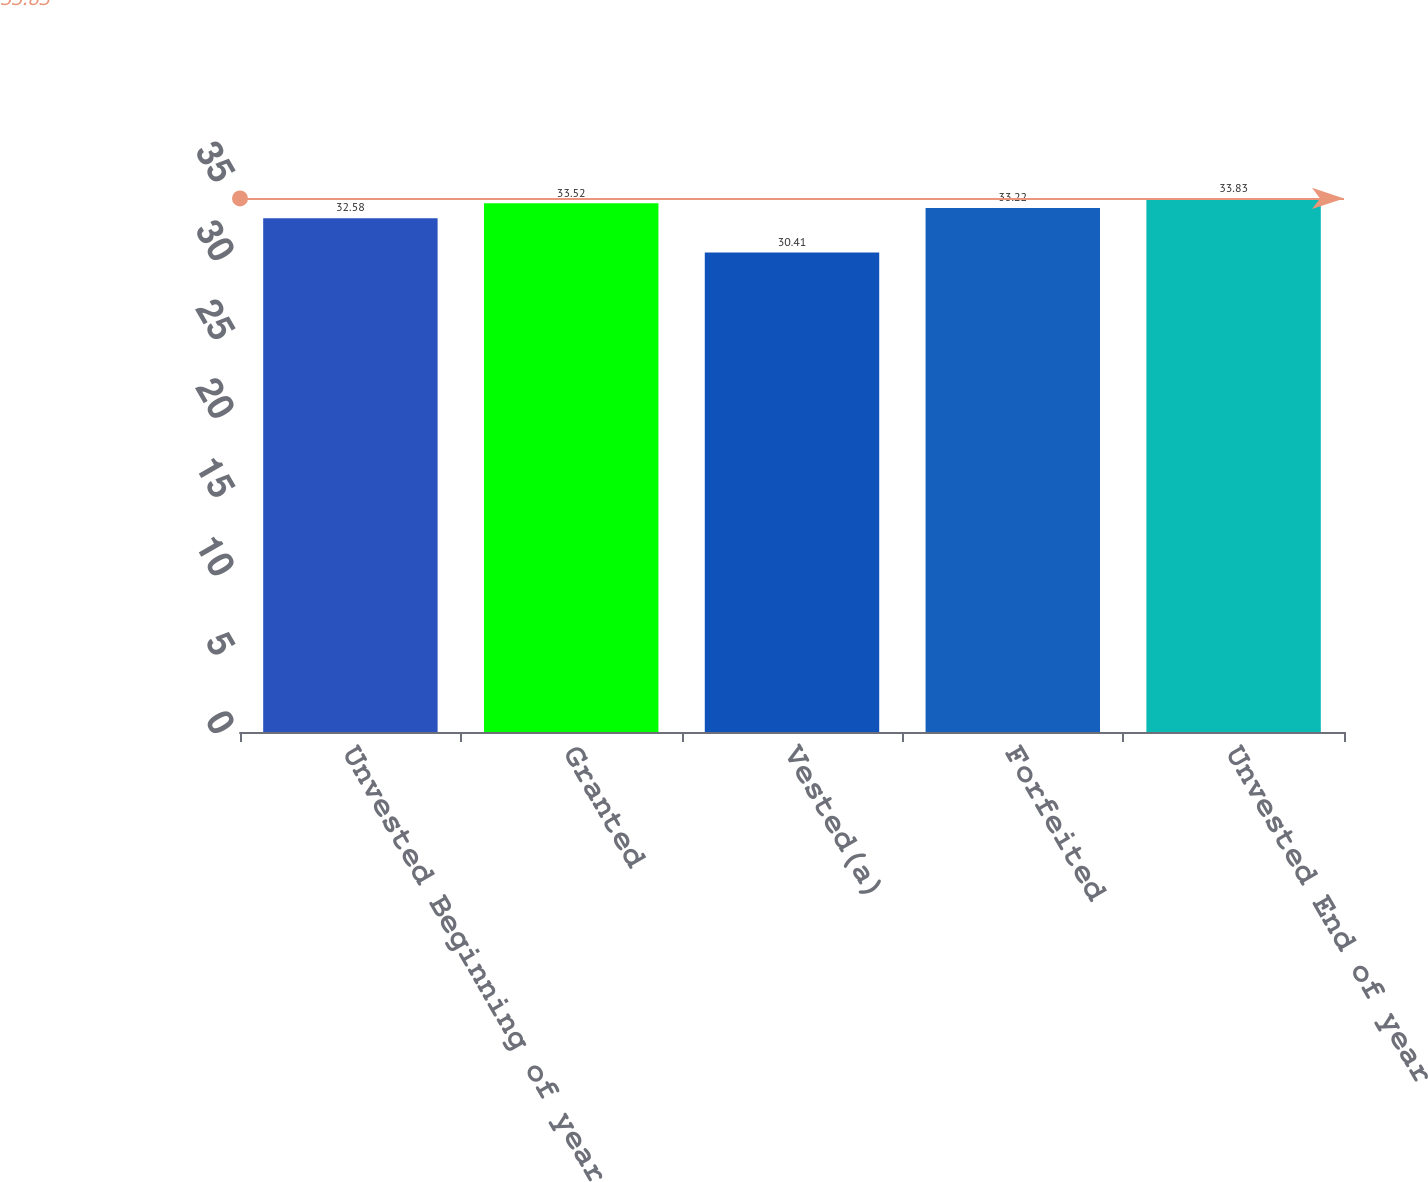Convert chart to OTSL. <chart><loc_0><loc_0><loc_500><loc_500><bar_chart><fcel>Unvested Beginning of year<fcel>Granted<fcel>Vested(a)<fcel>Forfeited<fcel>Unvested End of year<nl><fcel>32.58<fcel>33.52<fcel>30.41<fcel>33.22<fcel>33.83<nl></chart> 